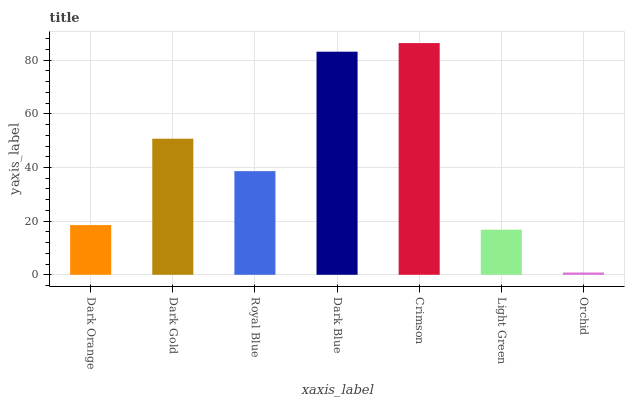Is Orchid the minimum?
Answer yes or no. Yes. Is Crimson the maximum?
Answer yes or no. Yes. Is Dark Gold the minimum?
Answer yes or no. No. Is Dark Gold the maximum?
Answer yes or no. No. Is Dark Gold greater than Dark Orange?
Answer yes or no. Yes. Is Dark Orange less than Dark Gold?
Answer yes or no. Yes. Is Dark Orange greater than Dark Gold?
Answer yes or no. No. Is Dark Gold less than Dark Orange?
Answer yes or no. No. Is Royal Blue the high median?
Answer yes or no. Yes. Is Royal Blue the low median?
Answer yes or no. Yes. Is Crimson the high median?
Answer yes or no. No. Is Dark Gold the low median?
Answer yes or no. No. 